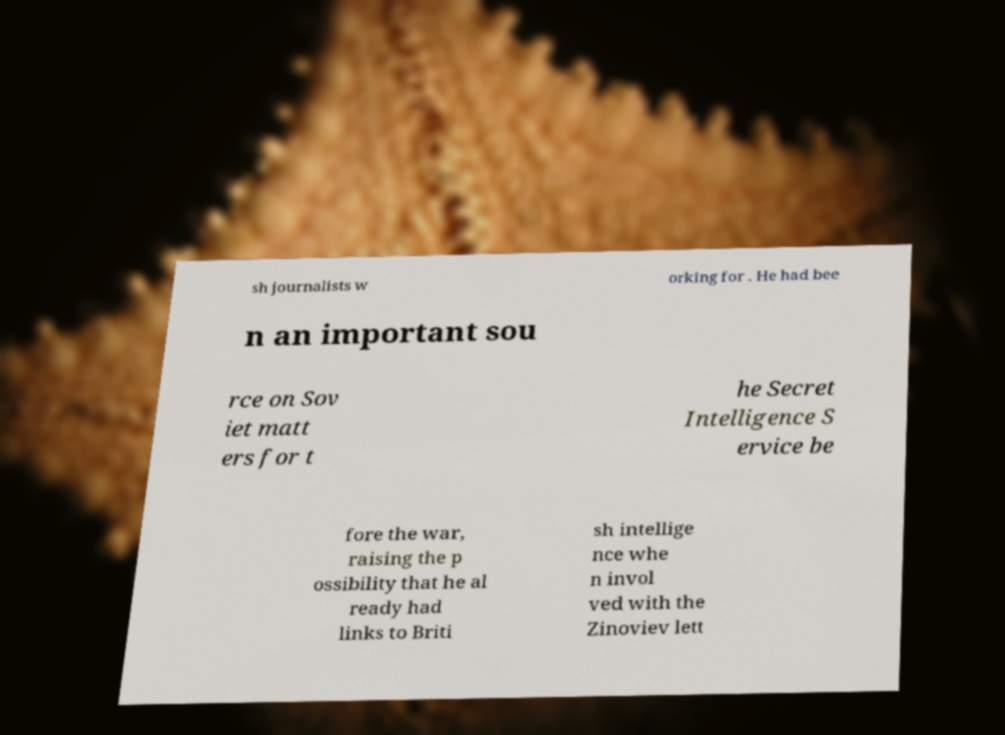Could you extract and type out the text from this image? sh journalists w orking for . He had bee n an important sou rce on Sov iet matt ers for t he Secret Intelligence S ervice be fore the war, raising the p ossibility that he al ready had links to Briti sh intellige nce whe n invol ved with the Zinoviev lett 